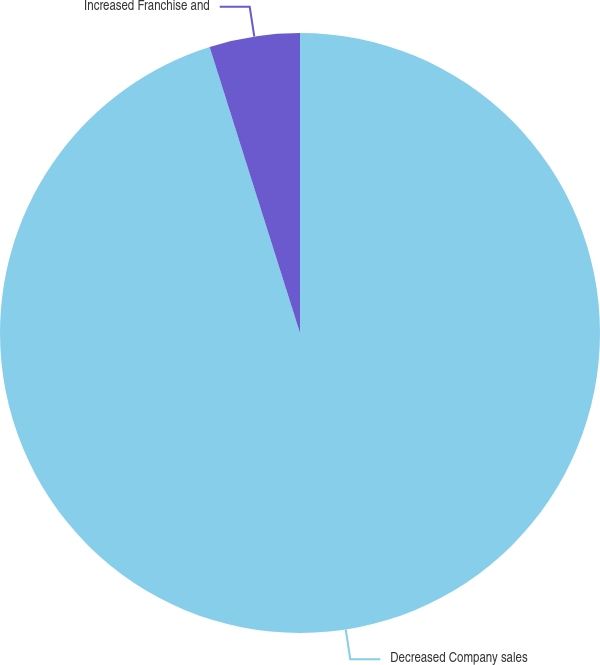Convert chart to OTSL. <chart><loc_0><loc_0><loc_500><loc_500><pie_chart><fcel>Decreased Company sales<fcel>Increased Franchise and<nl><fcel>95.13%<fcel>4.87%<nl></chart> 